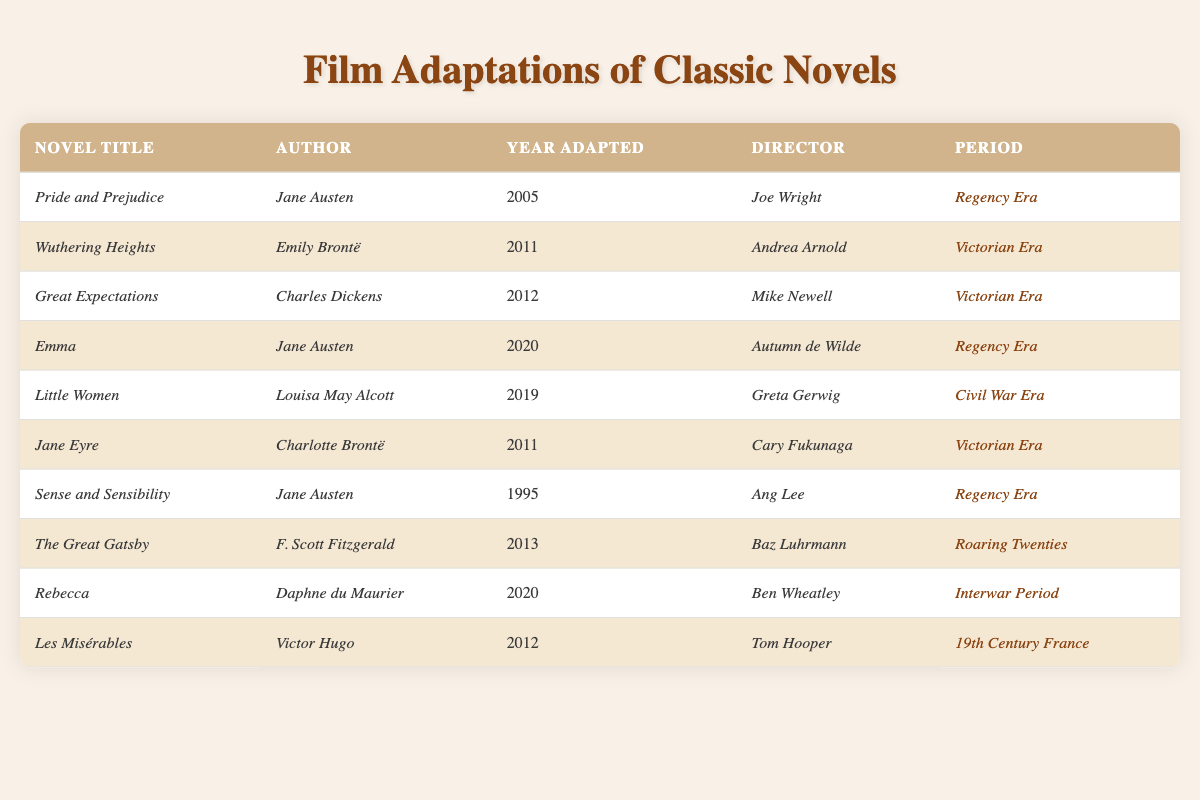What is the title of the film adaptation directed by Joe Wright? Referring to the table, the entry with the director named Joe Wright is for the novel titled *Pride and Prejudice*.
Answer: *Pride and Prejudice* How many film adaptations of novels by Jane Austen are listed? The table shows three adaptations by Jane Austen: *Pride and Prejudice*, *Emma*, and *Sense and Sensibility*. Therefore, the count is 3.
Answer: 3 Which period does *Little Women* belong to? According to the table, *Little Women* is categorized under the *Civil War Era*.
Answer: *Civil War Era* Is there a film adaptation of *Wuthering Heights* in the table? Yes, the table includes an adaptation of *Wuthering Heights* directed by Andrea Arnold in 2011.
Answer: Yes Which novel was adapted most recently according to the table? The most recent adaptation in the table is *Rebecca*, which was adapted in 2020.
Answer: *Rebecca* How many adaptations belong to the Victorian Era? The table lists four adaptations from the Victorian Era: *Wuthering Heights*, *Great Expectations*, *Jane Eyre*, and *Les Misérables*. This totals to 4 adaptations.
Answer: 4 What is the time gap between the adaptations of *Pride and Prejudice* and *Emma*? *Pride and Prejudice* was adapted in 2005, and *Emma* was adapted in 2020. The difference between these years is 2020 - 2005 = 15 years.
Answer: 15 years Which author has the most adaptations listed? Jane Austen appears three times in the adaptations listed in the table: *Pride and Prejudice*, *Emma*, and *Sense and Sensibility*.
Answer: Jane Austen Which adaptation directed by Baz Luhrmann is included in the table? The table shows that the adaptation directed by Baz Luhrmann is *The Great Gatsby*, released in 2013.
Answer: *The Great Gatsby* What are the titles of the films adapted from novels in the Regency Era? The table indicates two titles in the Regency Era: *Pride and Prejudice* and *Emma*.
Answer: *Pride and Prejudice*, *Emma* Is *Les Misérables* the only adaptation from 19th Century France? Yes, according to the table, *Les Misérables* is the only adaptation listed from 19th Century France.
Answer: Yes What is the total number of adaptations listed for the Victorian Era and the Civil War Era combined? The table lists four adaptations for the Victorian Era: *Wuthering Heights*, *Great Expectations*, *Jane Eyre*, and *Les Misérables*, and one adaptation for the Civil War Era: *Little Women*. Adding these together gives 4 + 1 = 5.
Answer: 5 